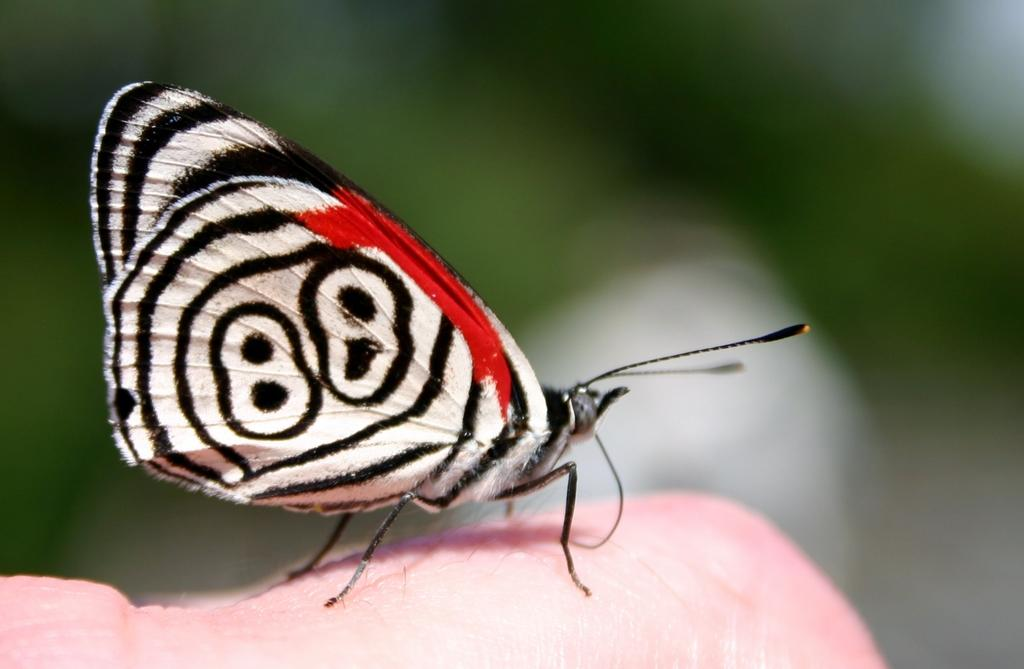What is the main subject of the image? There is a butterfly in the image. Where is the butterfly located? The butterfly is on a person's skin. What colors can be seen on the butterfly? The butterfly has black, white, and red colors. Can you describe the background of the image? The background of the image is blurred. What type of art can be seen in the image? There is no art present in the image; it features a butterfly on a person's skin. How many planes are visible in the image? There are no planes visible in the image. What is the butterfly using to cook in the image? Butterflies do not cook, and there is no oven present in the image. 